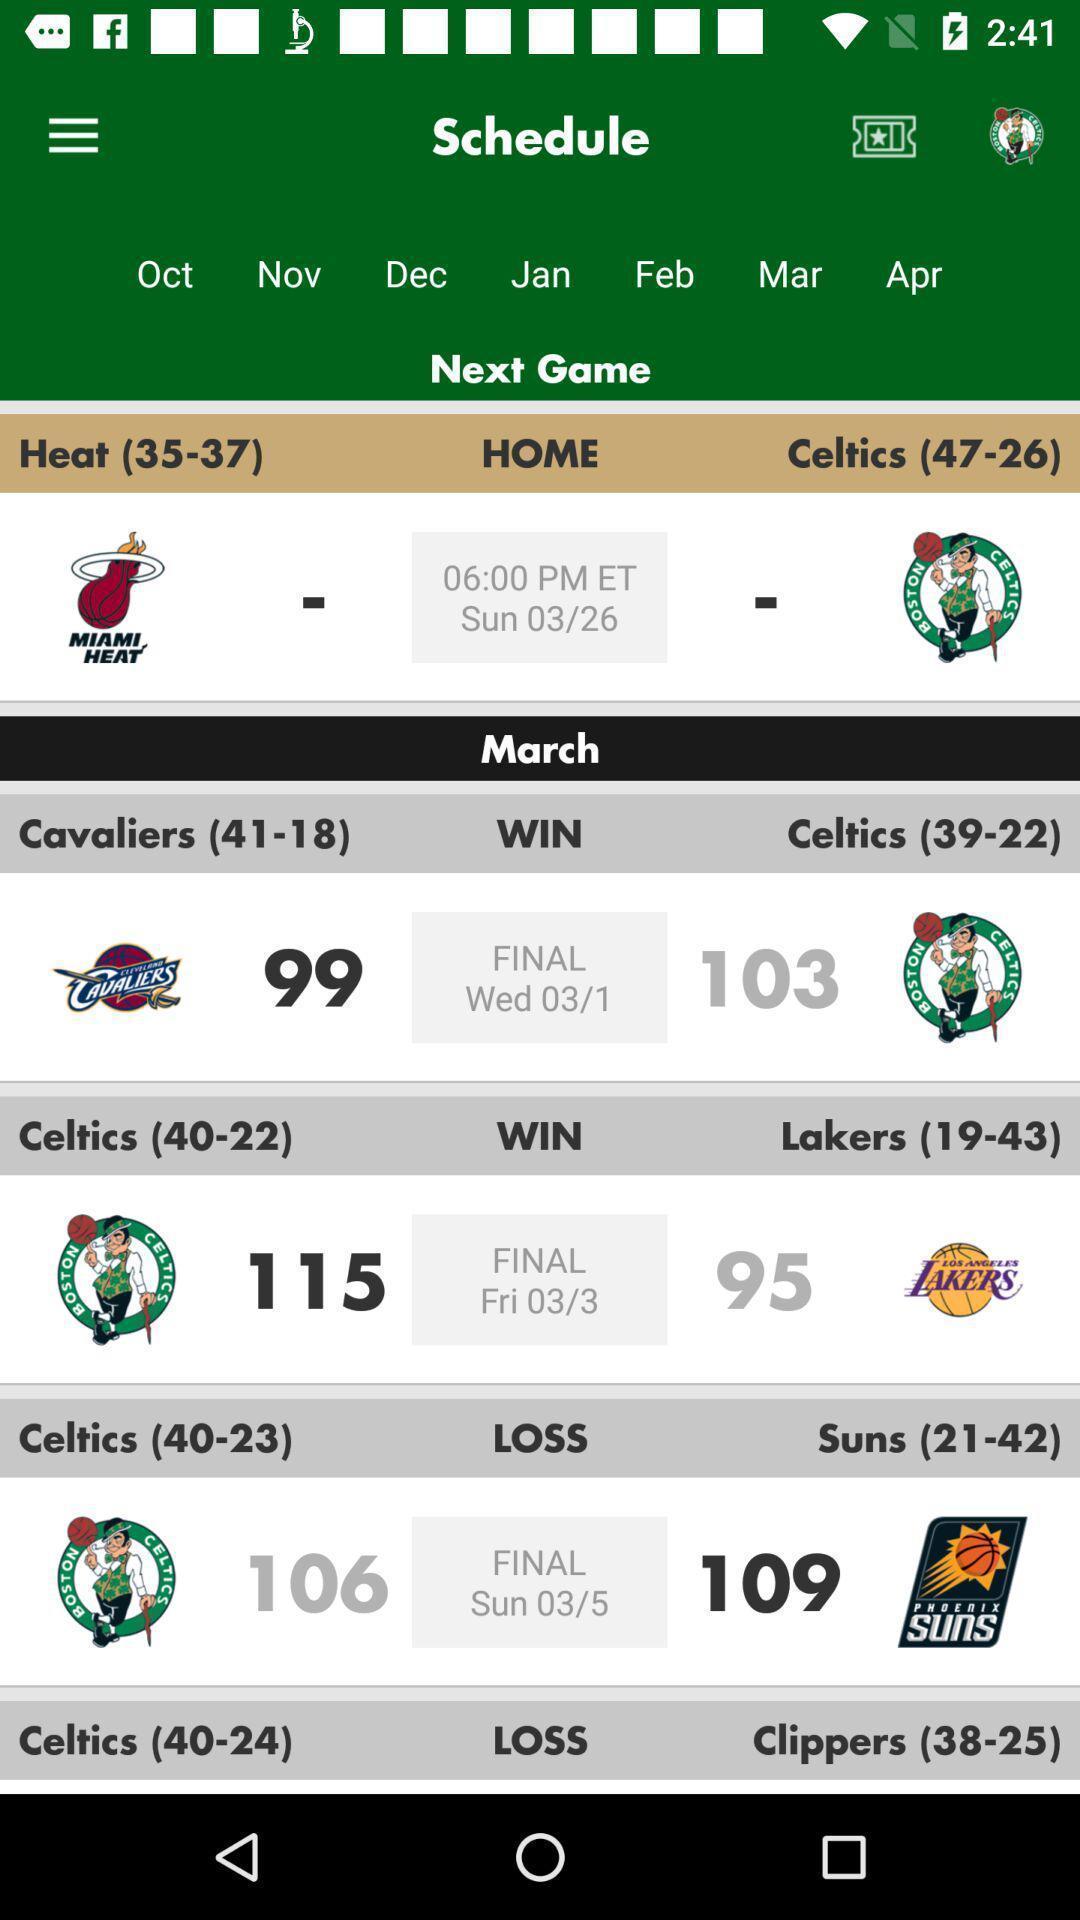Describe the key features of this screenshot. Teams schedule list showing in this page. 